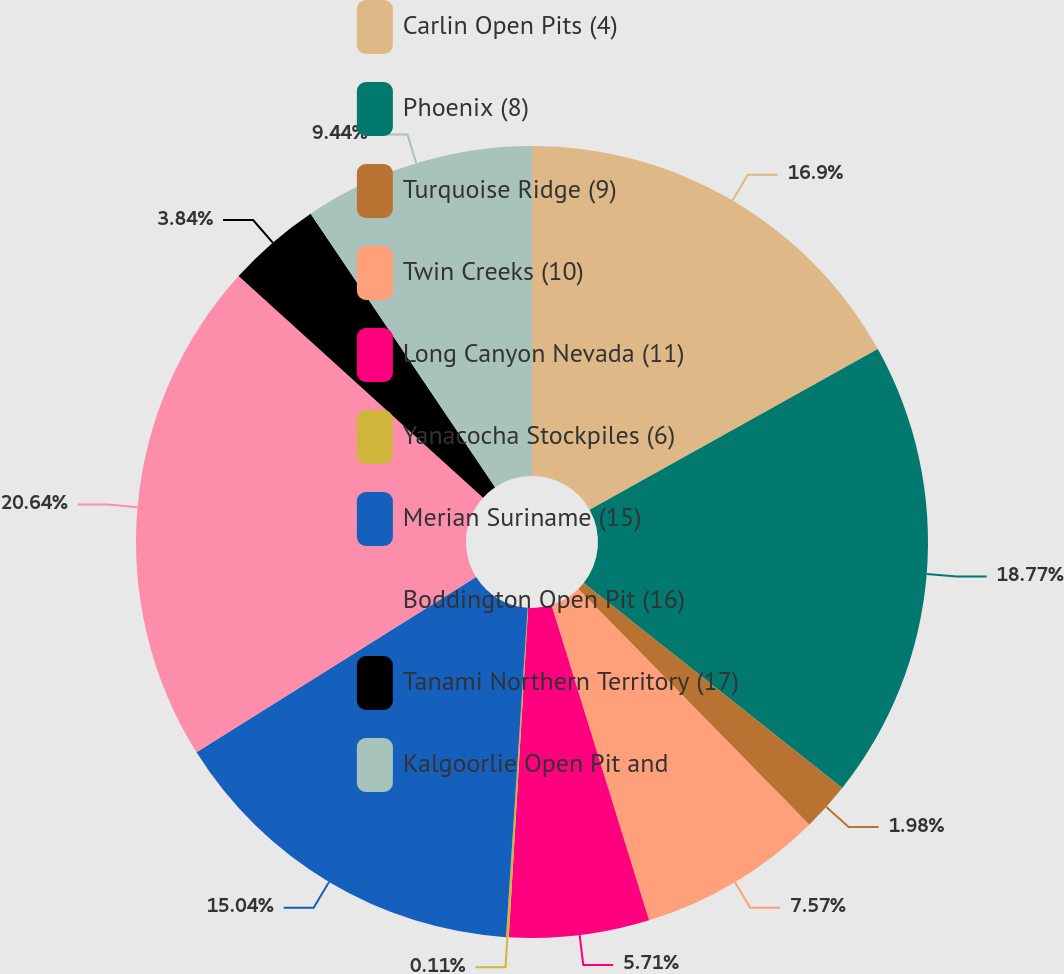<chart> <loc_0><loc_0><loc_500><loc_500><pie_chart><fcel>Carlin Open Pits (4)<fcel>Phoenix (8)<fcel>Turquoise Ridge (9)<fcel>Twin Creeks (10)<fcel>Long Canyon Nevada (11)<fcel>Yanacocha Stockpiles (6)<fcel>Merian Suriname (15)<fcel>Boddington Open Pit (16)<fcel>Tanami Northern Territory (17)<fcel>Kalgoorlie Open Pit and<nl><fcel>16.9%<fcel>18.77%<fcel>1.98%<fcel>7.57%<fcel>5.71%<fcel>0.11%<fcel>15.04%<fcel>20.63%<fcel>3.84%<fcel>9.44%<nl></chart> 